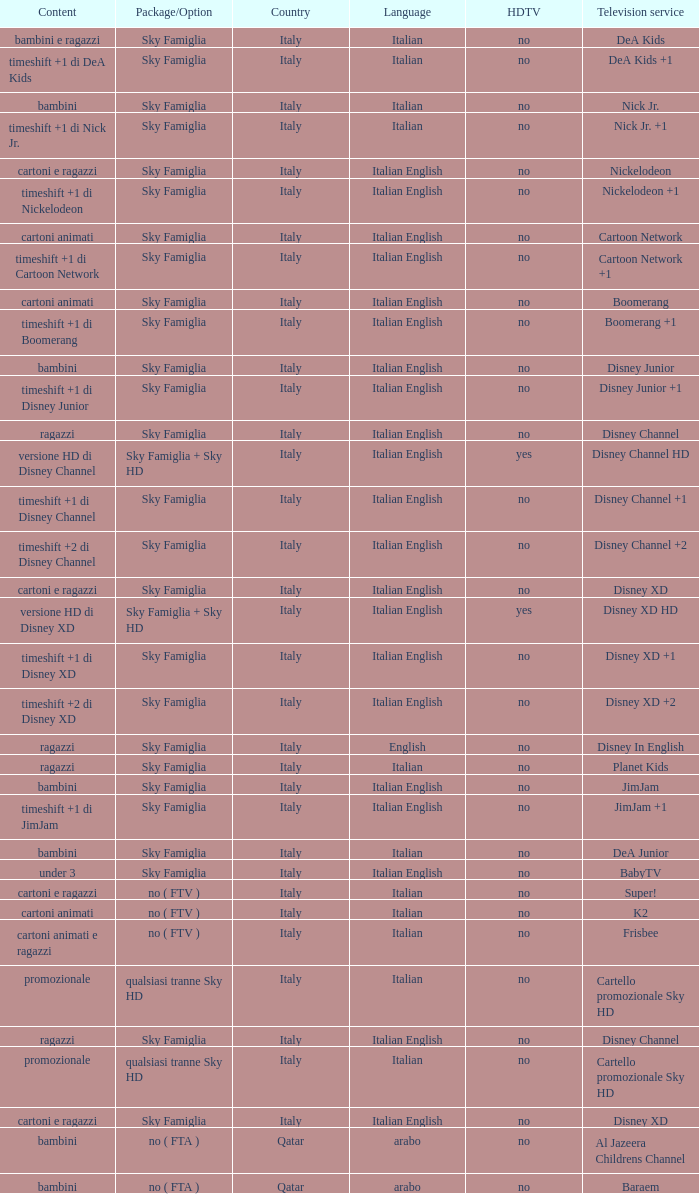What is the HDTV when the Package/Option is sky famiglia, and a Television service of boomerang +1? No. 